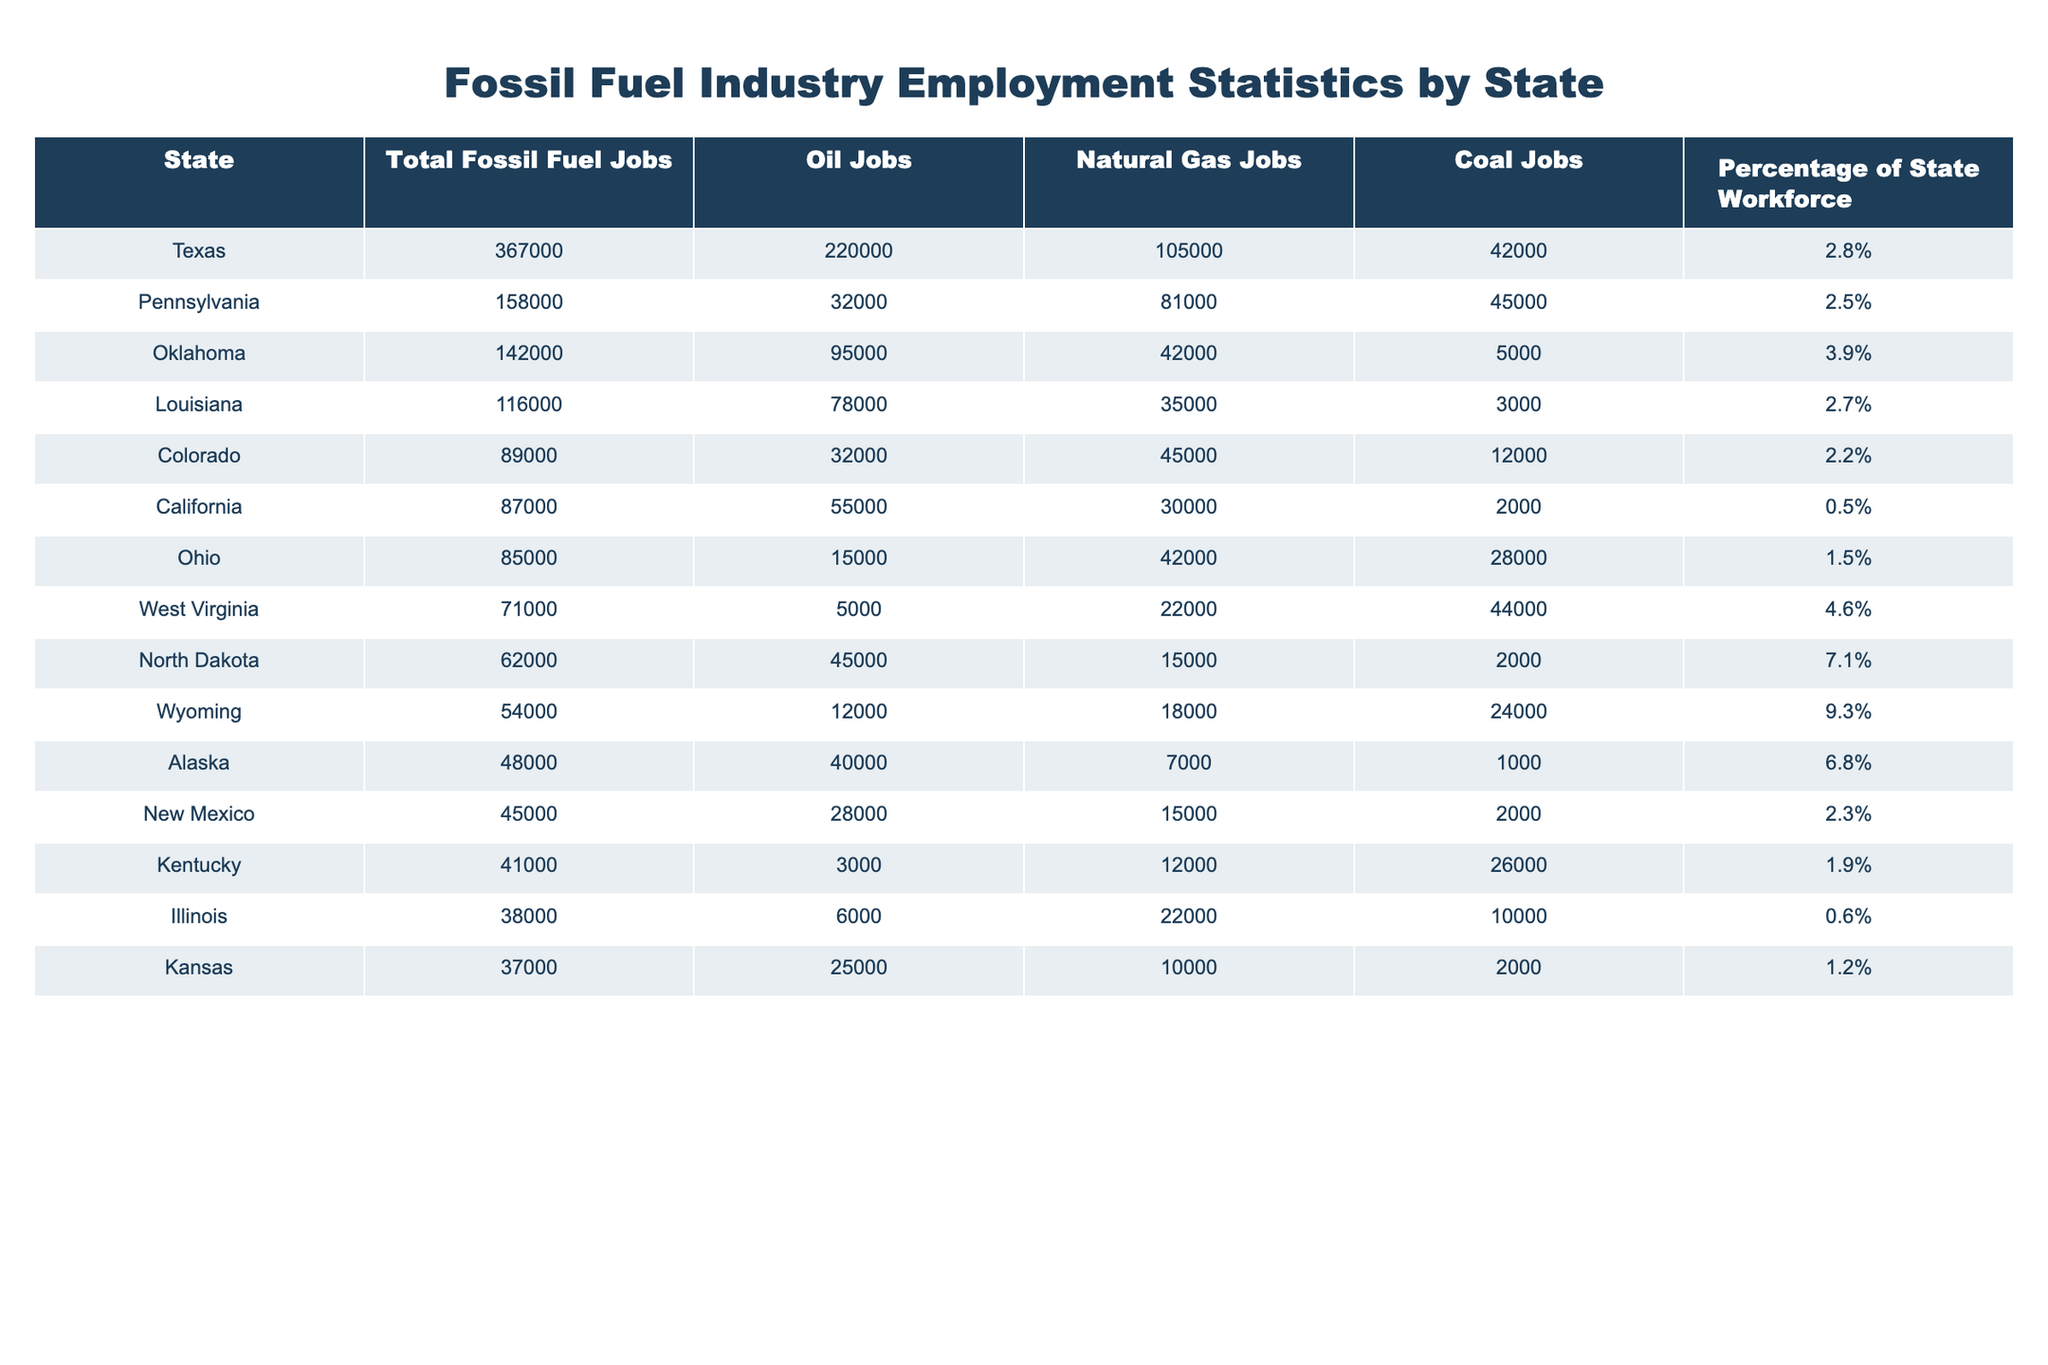What state has the highest total fossil fuel jobs? The total fossil fuel jobs for each state are listed. Texas has the highest number of total fossil fuel jobs at 367,000.
Answer: Texas Which state has the lowest percentage of its workforce in fossil fuel jobs? The percentage of the state workforce engaged in fossil fuel jobs is given for each state. California has the lowest percentage at 0.5%.
Answer: California What is the total number of oil jobs in Pennsylvania? The total column for oil jobs shows that Pennsylvania has 32,000 oil jobs.
Answer: 32,000 How many more fossil fuel jobs does Texas have than Oklahoma? Texas has 367,000 fossil fuel jobs and Oklahoma has 142,000. The difference is 367,000 - 142,000 = 225,000.
Answer: 225,000 Which state has the highest number of coal jobs? The coal job column indicates that West Virginia has the most coal jobs at 44,000.
Answer: West Virginia What is the average number of natural gas jobs across all states listed? Sum the natural gas jobs: 105,000 (Texas) + 81,000 (Pennsylvania) + 42,000 (Oklahoma) + ... + 10,000 (Kansas) = 478,000. There are 13 states in total, so the average is 478,000 / 13 ≈ 36,769.23.
Answer: Approximately 36,769 Is North Dakota the state with the highest number of fossil fuel jobs? North Dakota has 62,000 fossil fuel jobs, while Texas has 367,000. Thus, North Dakota is not the state with the highest fossil fuel jobs.
Answer: No What percentage of Oklahoma's workforce is engaged in fossil fuel jobs compared to the national average? Oklahoma's percentage is 3.9%. To determine if it is larger or smaller than the national average, I would need to calculate this average based on all states. However, if I consider only the numbers from the table, 3.9% is significant.
Answer: 3.9% is higher than many states but needs national data for the average If we combine the oil jobs of Texas and Louisiana, how many oil jobs do they account for? Texas has 220,000 oil jobs and Louisiana has 78,000. The total is 220,000 + 78,000 = 298,000.
Answer: 298,000 Which two states have the closest number of total fossil fuel jobs? Comparing total jobs, Illinois (38,000) and Kansas (37,000) are very close together. The difference is just 1,000.
Answer: Illinois and Kansas How many fossil fuel jobs does Wyoming have compared to North Dakota? Wyoming has 54,000 jobs while North Dakota has 62,000. The difference is 62,000 - 54,000 = 8,000.
Answer: 8,000 fewer jobs than North Dakota 